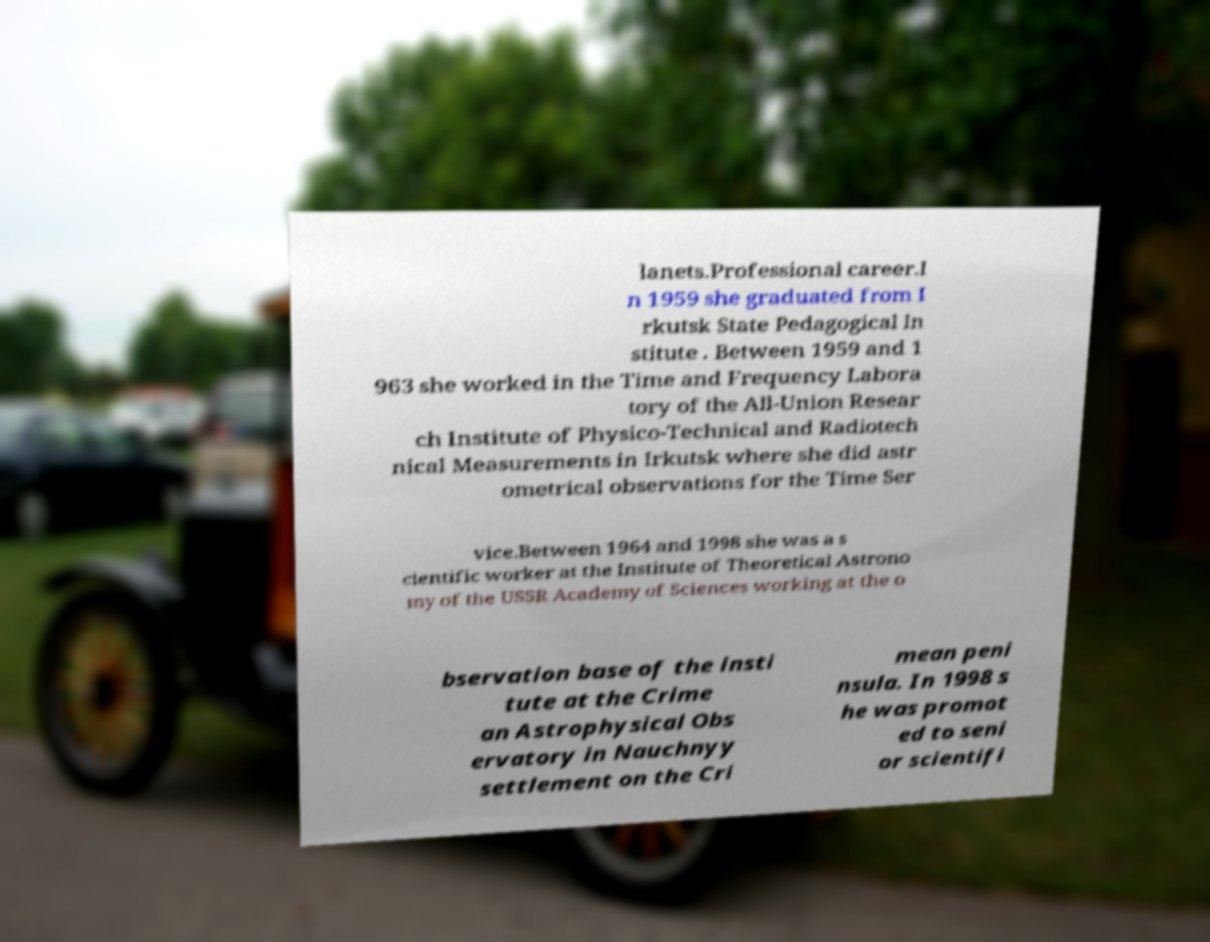Please read and relay the text visible in this image. What does it say? lanets.Professional career.I n 1959 she graduated from I rkutsk State Pedagogical In stitute . Between 1959 and 1 963 she worked in the Time and Frequency Labora tory of the All-Union Resear ch Institute of Physico-Technical and Radiotech nical Measurements in Irkutsk where she did astr ometrical observations for the Time Ser vice.Between 1964 and 1998 she was a s cientific worker at the Institute of Theoretical Astrono my of the USSR Academy of Sciences working at the o bservation base of the insti tute at the Crime an Astrophysical Obs ervatory in Nauchnyy settlement on the Cri mean peni nsula. In 1998 s he was promot ed to seni or scientifi 